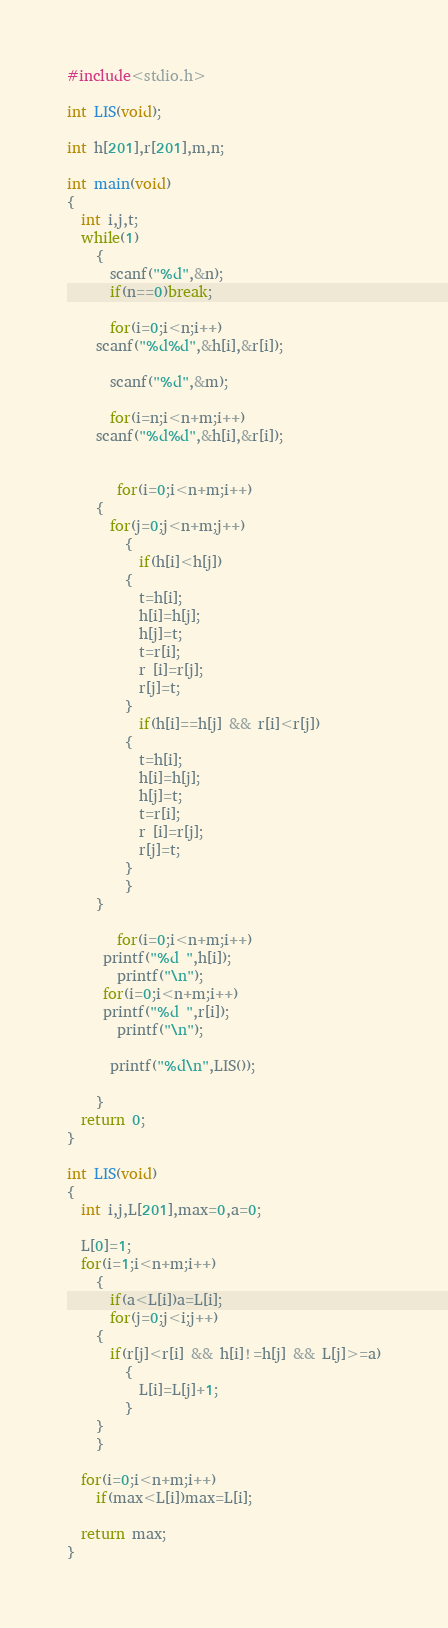<code> <loc_0><loc_0><loc_500><loc_500><_C_>#include<stdio.h>

int LIS(void);

int h[201],r[201],m,n;

int main(void)
{
  int i,j,t;
  while(1)
    {
      scanf("%d",&n);
      if(n==0)break;

      for(i=0;i<n;i++)
	scanf("%d%d",&h[i],&r[i]);

      scanf("%d",&m);

      for(i=n;i<n+m;i++)
	scanf("%d%d",&h[i],&r[i]);


       for(i=0;i<n+m;i++)
	{
	  for(j=0;j<n+m;j++)
	    {
	      if(h[i]<h[j])
		{
		  t=h[i];
		  h[i]=h[j];
		  h[j]=t;
		  t=r[i];
		  r [i]=r[j];
		  r[j]=t;
		}
	      if(h[i]==h[j] && r[i]<r[j])
		{
		  t=h[i];
		  h[i]=h[j];
		  h[j]=t;
		  t=r[i];
		  r [i]=r[j];
		  r[j]=t;
		}
	    }
	}

       for(i=0;i<n+m;i++)
	 printf("%d ",h[i]);
       printf("\n");
     for(i=0;i<n+m;i++)
	 printf("%d ",r[i]);
       printf("\n");

      printf("%d\n",LIS());

    }
  return 0;
}

int LIS(void)
{
  int i,j,L[201],max=0,a=0;

  L[0]=1;
  for(i=1;i<n+m;i++)
    {
      if(a<L[i])a=L[i];
      for(j=0;j<i;j++)
	{
	  if(r[j]<r[i] && h[i]!=h[j] && L[j]>=a)
	    {
	      L[i]=L[j]+1;
	    }
	}
    }

  for(i=0;i<n+m;i++)
    if(max<L[i])max=L[i];

  return max;
}</code> 